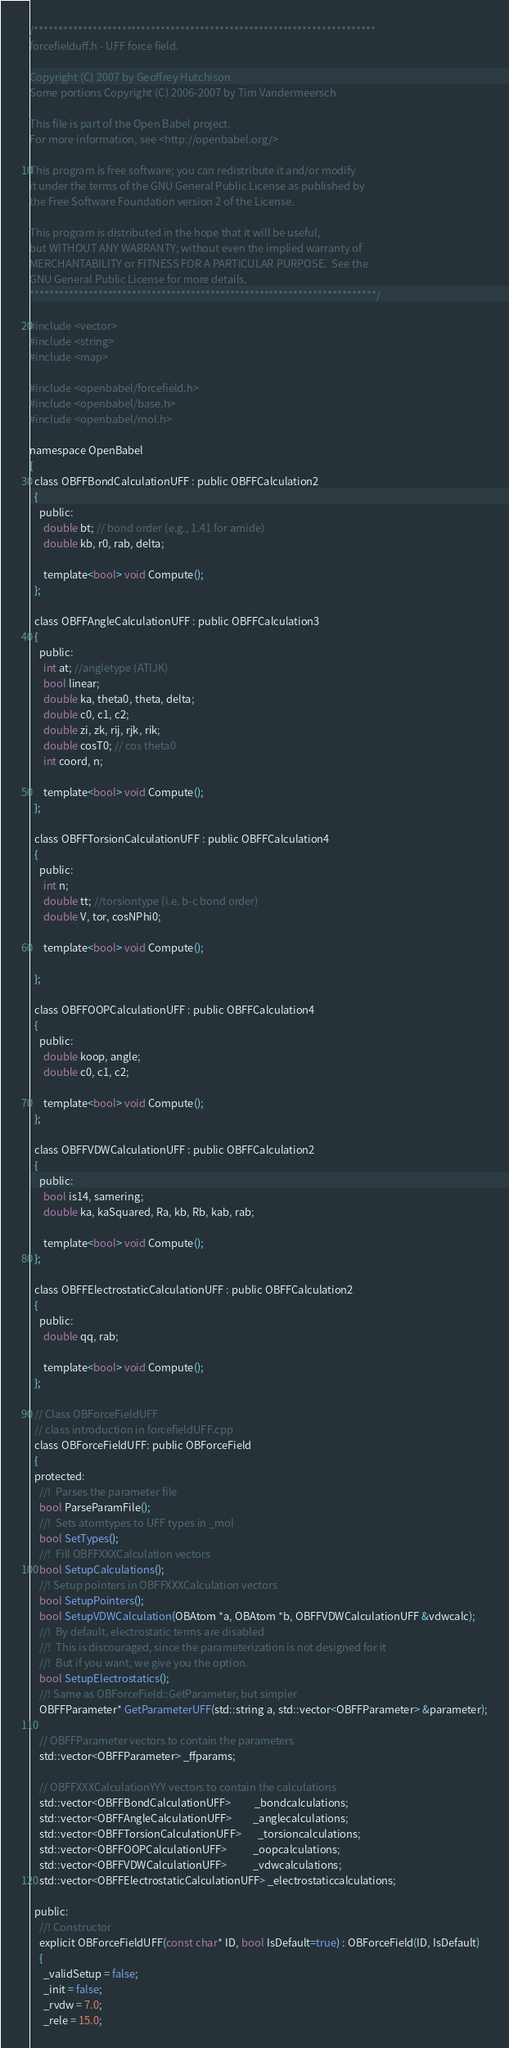Convert code to text. <code><loc_0><loc_0><loc_500><loc_500><_C_>/**********************************************************************
forcefielduff.h - UFF force field.

Copyright (C) 2007 by Geoffrey Hutchison
Some portions Copyright (C) 2006-2007 by Tim Vandermeersch

This file is part of the Open Babel project.
For more information, see <http://openbabel.org/>

This program is free software; you can redistribute it and/or modify
it under the terms of the GNU General Public License as published by
the Free Software Foundation version 2 of the License.

This program is distributed in the hope that it will be useful,
but WITHOUT ANY WARRANTY; without even the implied warranty of
MERCHANTABILITY or FITNESS FOR A PARTICULAR PURPOSE.  See the
GNU General Public License for more details.
***********************************************************************/

#include <vector>
#include <string>
#include <map>

#include <openbabel/forcefield.h>
#include <openbabel/base.h>
#include <openbabel/mol.h>

namespace OpenBabel
{
  class OBFFBondCalculationUFF : public OBFFCalculation2
  {
    public:
      double bt; // bond order (e.g., 1.41 for amide)
      double kb, r0, rab, delta;

      template<bool> void Compute();
  };

  class OBFFAngleCalculationUFF : public OBFFCalculation3
  {
    public:
      int at; //angletype (ATIJK)
      bool linear;
      double ka, theta0, theta, delta;
      double c0, c1, c2;
      double zi, zk, rij, rjk, rik;
      double cosT0; // cos theta0
      int coord, n;

      template<bool> void Compute();
  };

  class OBFFTorsionCalculationUFF : public OBFFCalculation4
  {
    public:
      int n;
      double tt; //torsiontype (i.e. b-c bond order)
      double V, tor, cosNPhi0;

      template<bool> void Compute();

  };

  class OBFFOOPCalculationUFF : public OBFFCalculation4
  {
    public:
      double koop, angle;
      double c0, c1, c2;

      template<bool> void Compute();
  };

  class OBFFVDWCalculationUFF : public OBFFCalculation2
  {
    public:
      bool is14, samering;
      double ka, kaSquared, Ra, kb, Rb, kab, rab;

      template<bool> void Compute();
  };

  class OBFFElectrostaticCalculationUFF : public OBFFCalculation2
  {
    public:
      double qq, rab;

      template<bool> void Compute();
  };

  // Class OBForceFieldUFF
  // class introduction in forcefieldUFF.cpp
  class OBForceFieldUFF: public OBForceField
  {
  protected:
    //!  Parses the parameter file
    bool ParseParamFile();
    //!  Sets atomtypes to UFF types in _mol
    bool SetTypes();
    //!  Fill OBFFXXXCalculation vectors
    bool SetupCalculations();
    //! Setup pointers in OBFFXXXCalculation vectors
    bool SetupPointers();
    bool SetupVDWCalculation(OBAtom *a, OBAtom *b, OBFFVDWCalculationUFF &vdwcalc);
    //!  By default, electrostatic terms are disabled
    //!  This is discouraged, since the parameterization is not designed for it
    //!  But if you want, we give you the option.
    bool SetupElectrostatics();
    //! Same as OBForceField::GetParameter, but simpler
    OBFFParameter* GetParameterUFF(std::string a, std::vector<OBFFParameter> &parameter);

    // OBFFParameter vectors to contain the parameters
    std::vector<OBFFParameter> _ffparams;

    // OBFFXXXCalculationYYY vectors to contain the calculations
    std::vector<OBFFBondCalculationUFF>          _bondcalculations;
    std::vector<OBFFAngleCalculationUFF>         _anglecalculations;
    std::vector<OBFFTorsionCalculationUFF>       _torsioncalculations;
    std::vector<OBFFOOPCalculationUFF>           _oopcalculations;
    std::vector<OBFFVDWCalculationUFF>           _vdwcalculations;
    std::vector<OBFFElectrostaticCalculationUFF> _electrostaticcalculations;

  public:
    //! Constructor
    explicit OBForceFieldUFF(const char* ID, bool IsDefault=true) : OBForceField(ID, IsDefault)
    {
      _validSetup = false;
      _init = false;
      _rvdw = 7.0;
      _rele = 15.0;</code> 